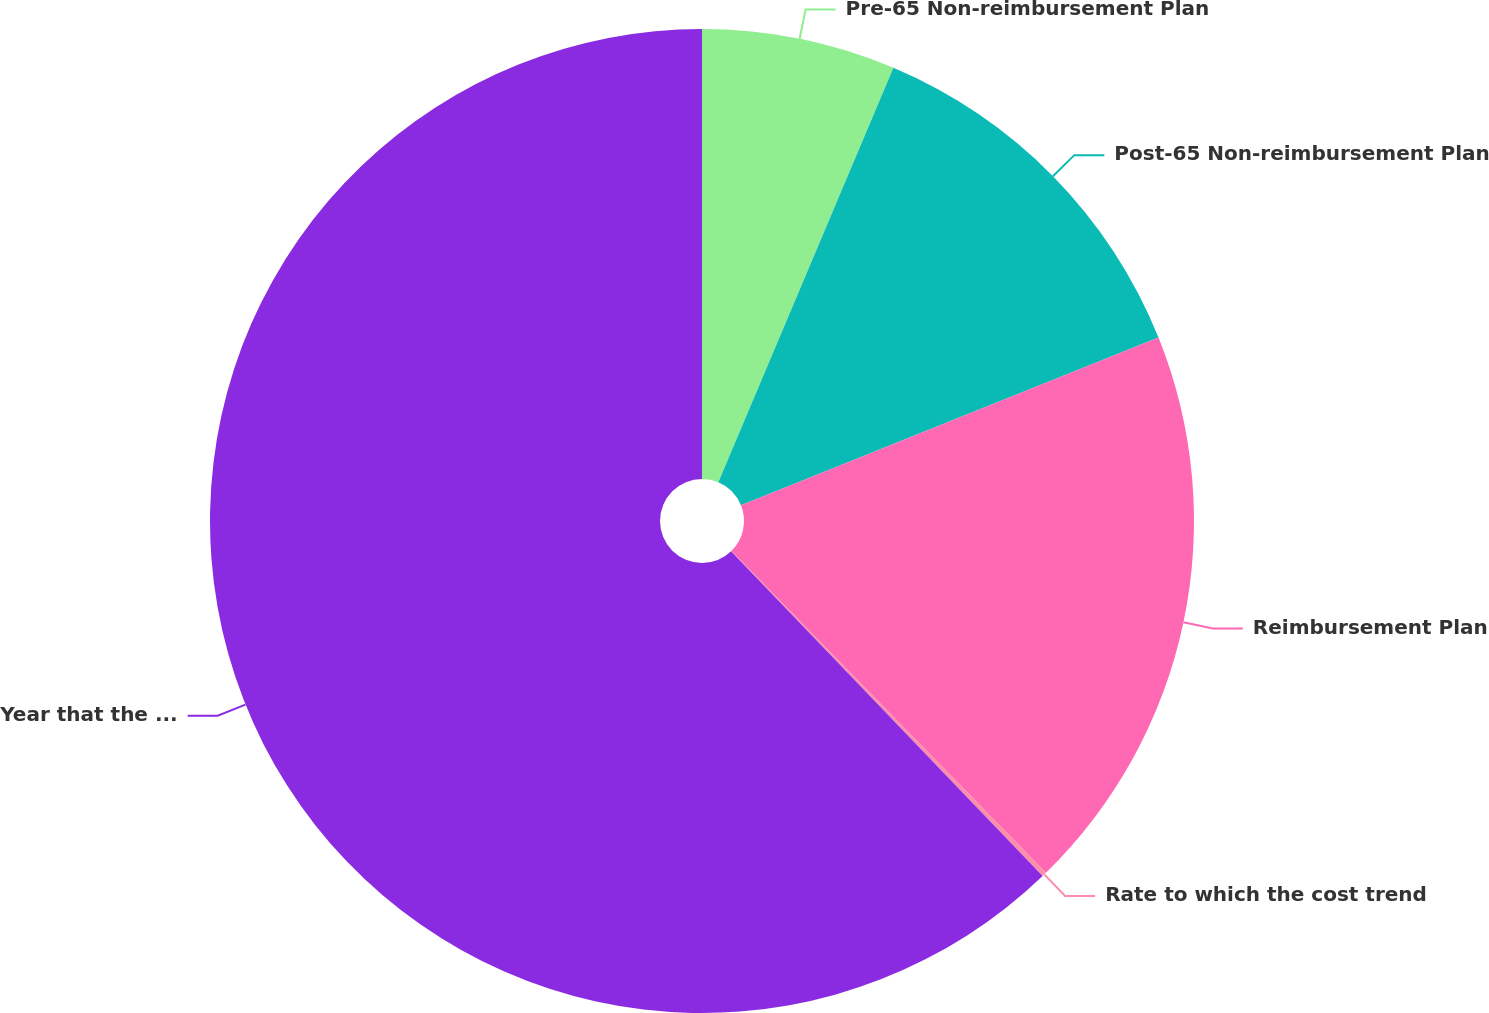Convert chart to OTSL. <chart><loc_0><loc_0><loc_500><loc_500><pie_chart><fcel>Pre-65 Non-reimbursement Plan<fcel>Post-65 Non-reimbursement Plan<fcel>Reimbursement Plan<fcel>Rate to which the cost trend<fcel>Year that the rate reaches the<nl><fcel>6.36%<fcel>12.56%<fcel>18.76%<fcel>0.15%<fcel>62.17%<nl></chart> 